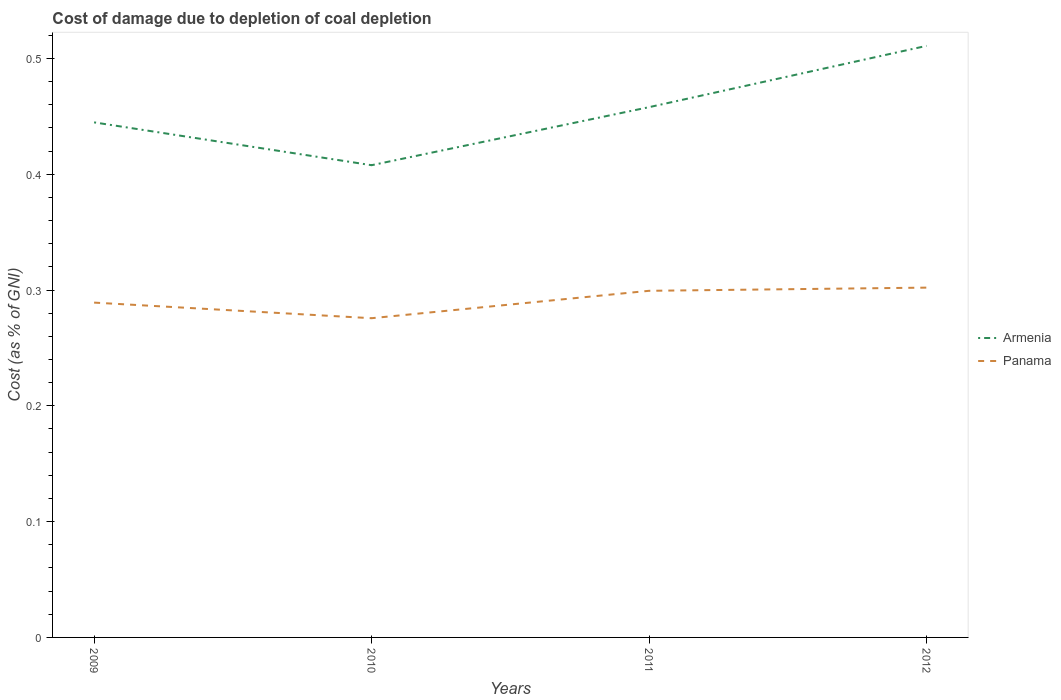How many different coloured lines are there?
Provide a succinct answer. 2. Does the line corresponding to Armenia intersect with the line corresponding to Panama?
Your response must be concise. No. Is the number of lines equal to the number of legend labels?
Make the answer very short. Yes. Across all years, what is the maximum cost of damage caused due to coal depletion in Panama?
Your answer should be very brief. 0.28. What is the total cost of damage caused due to coal depletion in Panama in the graph?
Offer a very short reply. -0. What is the difference between the highest and the second highest cost of damage caused due to coal depletion in Armenia?
Provide a short and direct response. 0.1. What is the difference between the highest and the lowest cost of damage caused due to coal depletion in Panama?
Your response must be concise. 2. Is the cost of damage caused due to coal depletion in Panama strictly greater than the cost of damage caused due to coal depletion in Armenia over the years?
Ensure brevity in your answer.  Yes. How many lines are there?
Make the answer very short. 2. What is the difference between two consecutive major ticks on the Y-axis?
Your answer should be very brief. 0.1. Are the values on the major ticks of Y-axis written in scientific E-notation?
Offer a terse response. No. Does the graph contain any zero values?
Keep it short and to the point. No. How many legend labels are there?
Offer a very short reply. 2. What is the title of the graph?
Provide a short and direct response. Cost of damage due to depletion of coal depletion. What is the label or title of the Y-axis?
Provide a succinct answer. Cost (as % of GNI). What is the Cost (as % of GNI) of Armenia in 2009?
Keep it short and to the point. 0.44. What is the Cost (as % of GNI) of Panama in 2009?
Provide a succinct answer. 0.29. What is the Cost (as % of GNI) of Armenia in 2010?
Provide a succinct answer. 0.41. What is the Cost (as % of GNI) of Panama in 2010?
Your answer should be very brief. 0.28. What is the Cost (as % of GNI) of Armenia in 2011?
Give a very brief answer. 0.46. What is the Cost (as % of GNI) in Panama in 2011?
Your response must be concise. 0.3. What is the Cost (as % of GNI) of Armenia in 2012?
Keep it short and to the point. 0.51. What is the Cost (as % of GNI) in Panama in 2012?
Your answer should be compact. 0.3. Across all years, what is the maximum Cost (as % of GNI) of Armenia?
Give a very brief answer. 0.51. Across all years, what is the maximum Cost (as % of GNI) in Panama?
Your response must be concise. 0.3. Across all years, what is the minimum Cost (as % of GNI) in Armenia?
Make the answer very short. 0.41. Across all years, what is the minimum Cost (as % of GNI) in Panama?
Ensure brevity in your answer.  0.28. What is the total Cost (as % of GNI) of Armenia in the graph?
Ensure brevity in your answer.  1.82. What is the total Cost (as % of GNI) in Panama in the graph?
Your answer should be very brief. 1.17. What is the difference between the Cost (as % of GNI) of Armenia in 2009 and that in 2010?
Your response must be concise. 0.04. What is the difference between the Cost (as % of GNI) of Panama in 2009 and that in 2010?
Provide a short and direct response. 0.01. What is the difference between the Cost (as % of GNI) of Armenia in 2009 and that in 2011?
Your answer should be compact. -0.01. What is the difference between the Cost (as % of GNI) of Panama in 2009 and that in 2011?
Your answer should be compact. -0.01. What is the difference between the Cost (as % of GNI) in Armenia in 2009 and that in 2012?
Make the answer very short. -0.07. What is the difference between the Cost (as % of GNI) in Panama in 2009 and that in 2012?
Give a very brief answer. -0.01. What is the difference between the Cost (as % of GNI) in Armenia in 2010 and that in 2011?
Offer a terse response. -0.05. What is the difference between the Cost (as % of GNI) in Panama in 2010 and that in 2011?
Ensure brevity in your answer.  -0.02. What is the difference between the Cost (as % of GNI) in Armenia in 2010 and that in 2012?
Your answer should be compact. -0.1. What is the difference between the Cost (as % of GNI) of Panama in 2010 and that in 2012?
Provide a succinct answer. -0.03. What is the difference between the Cost (as % of GNI) of Armenia in 2011 and that in 2012?
Your answer should be compact. -0.05. What is the difference between the Cost (as % of GNI) of Panama in 2011 and that in 2012?
Keep it short and to the point. -0. What is the difference between the Cost (as % of GNI) of Armenia in 2009 and the Cost (as % of GNI) of Panama in 2010?
Make the answer very short. 0.17. What is the difference between the Cost (as % of GNI) in Armenia in 2009 and the Cost (as % of GNI) in Panama in 2011?
Make the answer very short. 0.15. What is the difference between the Cost (as % of GNI) in Armenia in 2009 and the Cost (as % of GNI) in Panama in 2012?
Provide a succinct answer. 0.14. What is the difference between the Cost (as % of GNI) of Armenia in 2010 and the Cost (as % of GNI) of Panama in 2011?
Offer a terse response. 0.11. What is the difference between the Cost (as % of GNI) of Armenia in 2010 and the Cost (as % of GNI) of Panama in 2012?
Your response must be concise. 0.11. What is the difference between the Cost (as % of GNI) in Armenia in 2011 and the Cost (as % of GNI) in Panama in 2012?
Provide a succinct answer. 0.16. What is the average Cost (as % of GNI) in Armenia per year?
Your answer should be compact. 0.46. What is the average Cost (as % of GNI) in Panama per year?
Provide a short and direct response. 0.29. In the year 2009, what is the difference between the Cost (as % of GNI) in Armenia and Cost (as % of GNI) in Panama?
Keep it short and to the point. 0.16. In the year 2010, what is the difference between the Cost (as % of GNI) of Armenia and Cost (as % of GNI) of Panama?
Your response must be concise. 0.13. In the year 2011, what is the difference between the Cost (as % of GNI) in Armenia and Cost (as % of GNI) in Panama?
Give a very brief answer. 0.16. In the year 2012, what is the difference between the Cost (as % of GNI) of Armenia and Cost (as % of GNI) of Panama?
Provide a short and direct response. 0.21. What is the ratio of the Cost (as % of GNI) of Armenia in 2009 to that in 2010?
Your answer should be compact. 1.09. What is the ratio of the Cost (as % of GNI) in Panama in 2009 to that in 2010?
Your answer should be very brief. 1.05. What is the ratio of the Cost (as % of GNI) in Armenia in 2009 to that in 2011?
Keep it short and to the point. 0.97. What is the ratio of the Cost (as % of GNI) in Panama in 2009 to that in 2011?
Give a very brief answer. 0.97. What is the ratio of the Cost (as % of GNI) in Armenia in 2009 to that in 2012?
Give a very brief answer. 0.87. What is the ratio of the Cost (as % of GNI) in Panama in 2009 to that in 2012?
Your answer should be very brief. 0.96. What is the ratio of the Cost (as % of GNI) of Armenia in 2010 to that in 2011?
Provide a short and direct response. 0.89. What is the ratio of the Cost (as % of GNI) of Panama in 2010 to that in 2011?
Give a very brief answer. 0.92. What is the ratio of the Cost (as % of GNI) of Armenia in 2010 to that in 2012?
Keep it short and to the point. 0.8. What is the ratio of the Cost (as % of GNI) of Panama in 2010 to that in 2012?
Give a very brief answer. 0.91. What is the ratio of the Cost (as % of GNI) in Armenia in 2011 to that in 2012?
Provide a short and direct response. 0.9. What is the ratio of the Cost (as % of GNI) of Panama in 2011 to that in 2012?
Provide a short and direct response. 0.99. What is the difference between the highest and the second highest Cost (as % of GNI) in Armenia?
Keep it short and to the point. 0.05. What is the difference between the highest and the second highest Cost (as % of GNI) in Panama?
Make the answer very short. 0. What is the difference between the highest and the lowest Cost (as % of GNI) of Armenia?
Give a very brief answer. 0.1. What is the difference between the highest and the lowest Cost (as % of GNI) of Panama?
Offer a terse response. 0.03. 